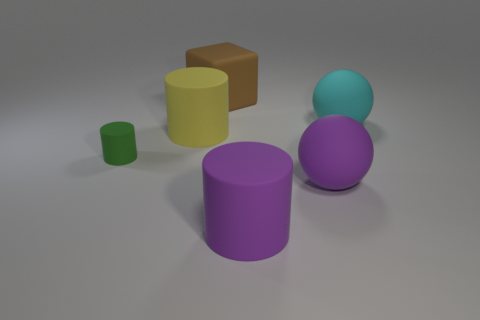There is a cylinder that is to the left of the big cylinder that is behind the big purple thing that is behind the purple matte cylinder; what size is it?
Your answer should be very brief. Small. What is the color of the large object that is left of the big purple rubber cylinder and to the right of the big yellow matte object?
Offer a terse response. Brown. There is a ball behind the tiny green rubber thing; how big is it?
Your answer should be very brief. Large. What number of large cyan objects have the same material as the cyan ball?
Provide a succinct answer. 0. Is the shape of the thing that is left of the yellow rubber cylinder the same as  the large yellow rubber thing?
Your answer should be compact. Yes. There is another small object that is made of the same material as the cyan object; what color is it?
Your response must be concise. Green. Is there a purple matte thing to the left of the big purple object that is behind the cylinder on the right side of the large yellow rubber object?
Offer a very short reply. Yes. What shape is the green thing?
Your answer should be compact. Cylinder. Are there fewer big yellow things that are in front of the big purple rubber ball than large rubber objects?
Ensure brevity in your answer.  Yes. Is there a tiny green object of the same shape as the yellow object?
Keep it short and to the point. Yes. 